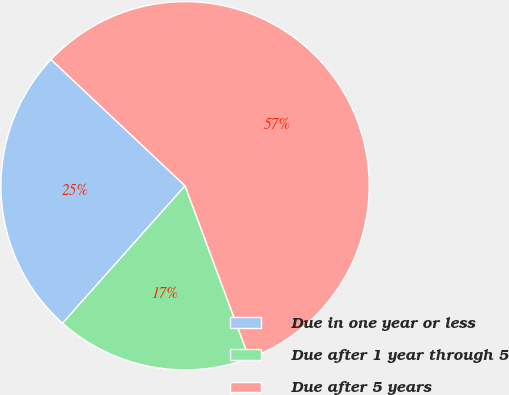Convert chart to OTSL. <chart><loc_0><loc_0><loc_500><loc_500><pie_chart><fcel>Due in one year or less<fcel>Due after 1 year through 5<fcel>Due after 5 years<nl><fcel>25.44%<fcel>17.25%<fcel>57.32%<nl></chart> 